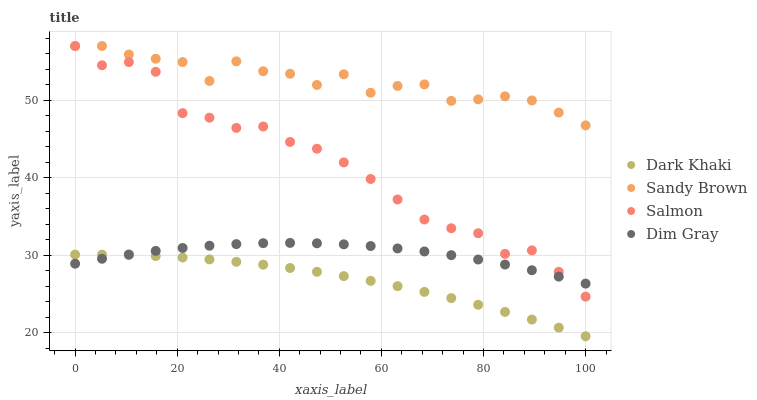Does Dark Khaki have the minimum area under the curve?
Answer yes or no. Yes. Does Sandy Brown have the maximum area under the curve?
Answer yes or no. Yes. Does Salmon have the minimum area under the curve?
Answer yes or no. No. Does Salmon have the maximum area under the curve?
Answer yes or no. No. Is Dark Khaki the smoothest?
Answer yes or no. Yes. Is Sandy Brown the roughest?
Answer yes or no. Yes. Is Salmon the smoothest?
Answer yes or no. No. Is Salmon the roughest?
Answer yes or no. No. Does Dark Khaki have the lowest value?
Answer yes or no. Yes. Does Salmon have the lowest value?
Answer yes or no. No. Does Sandy Brown have the highest value?
Answer yes or no. Yes. Does Dim Gray have the highest value?
Answer yes or no. No. Is Dark Khaki less than Sandy Brown?
Answer yes or no. Yes. Is Sandy Brown greater than Dark Khaki?
Answer yes or no. Yes. Does Salmon intersect Sandy Brown?
Answer yes or no. Yes. Is Salmon less than Sandy Brown?
Answer yes or no. No. Is Salmon greater than Sandy Brown?
Answer yes or no. No. Does Dark Khaki intersect Sandy Brown?
Answer yes or no. No. 